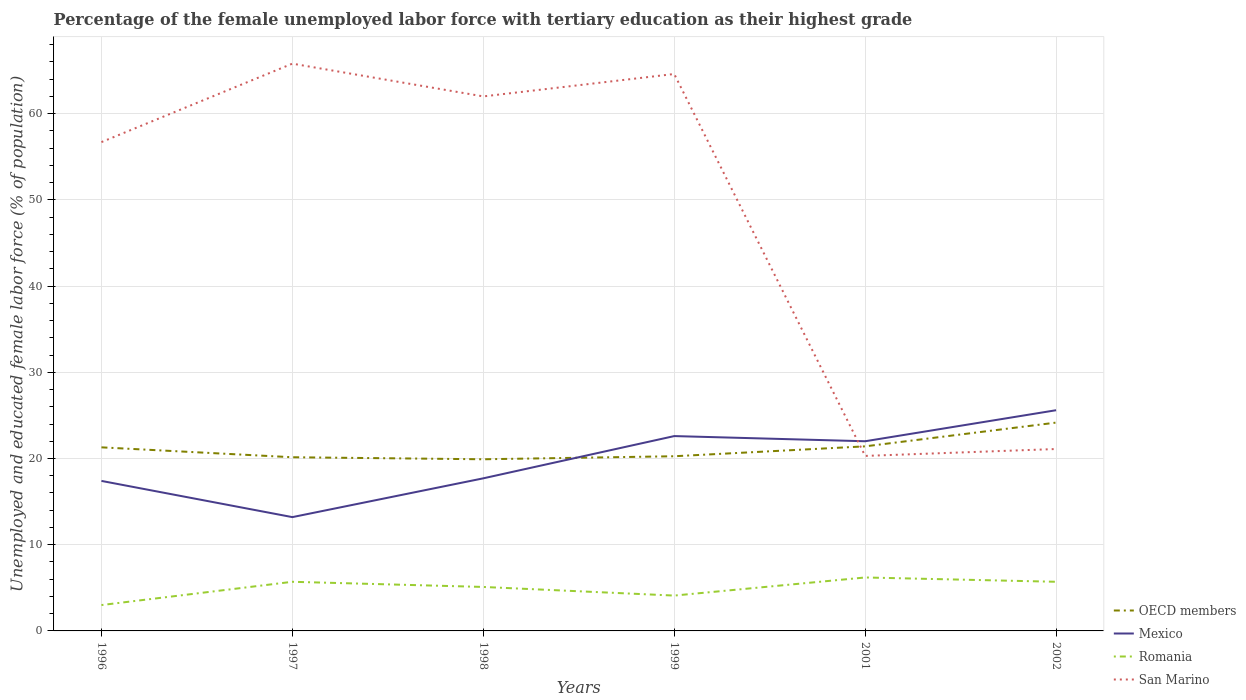Is the number of lines equal to the number of legend labels?
Provide a short and direct response. Yes. Across all years, what is the maximum percentage of the unemployed female labor force with tertiary education in San Marino?
Ensure brevity in your answer.  20.3. What is the total percentage of the unemployed female labor force with tertiary education in Mexico in the graph?
Make the answer very short. -5.2. What is the difference between the highest and the second highest percentage of the unemployed female labor force with tertiary education in OECD members?
Provide a succinct answer. 4.25. What is the difference between the highest and the lowest percentage of the unemployed female labor force with tertiary education in Mexico?
Keep it short and to the point. 3. What is the difference between two consecutive major ticks on the Y-axis?
Keep it short and to the point. 10. Are the values on the major ticks of Y-axis written in scientific E-notation?
Offer a very short reply. No. Does the graph contain any zero values?
Ensure brevity in your answer.  No. Does the graph contain grids?
Provide a short and direct response. Yes. Where does the legend appear in the graph?
Give a very brief answer. Bottom right. How many legend labels are there?
Ensure brevity in your answer.  4. How are the legend labels stacked?
Your response must be concise. Vertical. What is the title of the graph?
Your response must be concise. Percentage of the female unemployed labor force with tertiary education as their highest grade. What is the label or title of the Y-axis?
Keep it short and to the point. Unemployed and educated female labor force (% of population). What is the Unemployed and educated female labor force (% of population) of OECD members in 1996?
Ensure brevity in your answer.  21.29. What is the Unemployed and educated female labor force (% of population) in Mexico in 1996?
Your answer should be very brief. 17.4. What is the Unemployed and educated female labor force (% of population) in Romania in 1996?
Offer a terse response. 3. What is the Unemployed and educated female labor force (% of population) in San Marino in 1996?
Keep it short and to the point. 56.7. What is the Unemployed and educated female labor force (% of population) of OECD members in 1997?
Offer a terse response. 20.15. What is the Unemployed and educated female labor force (% of population) of Mexico in 1997?
Your answer should be compact. 13.2. What is the Unemployed and educated female labor force (% of population) in Romania in 1997?
Your answer should be very brief. 5.7. What is the Unemployed and educated female labor force (% of population) of San Marino in 1997?
Your answer should be very brief. 65.8. What is the Unemployed and educated female labor force (% of population) of OECD members in 1998?
Offer a terse response. 19.91. What is the Unemployed and educated female labor force (% of population) of Mexico in 1998?
Ensure brevity in your answer.  17.7. What is the Unemployed and educated female labor force (% of population) of Romania in 1998?
Provide a short and direct response. 5.1. What is the Unemployed and educated female labor force (% of population) of San Marino in 1998?
Give a very brief answer. 62. What is the Unemployed and educated female labor force (% of population) of OECD members in 1999?
Keep it short and to the point. 20.26. What is the Unemployed and educated female labor force (% of population) in Mexico in 1999?
Provide a short and direct response. 22.6. What is the Unemployed and educated female labor force (% of population) of Romania in 1999?
Keep it short and to the point. 4.1. What is the Unemployed and educated female labor force (% of population) in San Marino in 1999?
Your response must be concise. 64.6. What is the Unemployed and educated female labor force (% of population) in OECD members in 2001?
Provide a succinct answer. 21.41. What is the Unemployed and educated female labor force (% of population) in Mexico in 2001?
Your answer should be very brief. 22. What is the Unemployed and educated female labor force (% of population) in Romania in 2001?
Your answer should be very brief. 6.2. What is the Unemployed and educated female labor force (% of population) of San Marino in 2001?
Ensure brevity in your answer.  20.3. What is the Unemployed and educated female labor force (% of population) in OECD members in 2002?
Give a very brief answer. 24.16. What is the Unemployed and educated female labor force (% of population) in Mexico in 2002?
Keep it short and to the point. 25.6. What is the Unemployed and educated female labor force (% of population) of Romania in 2002?
Ensure brevity in your answer.  5.7. What is the Unemployed and educated female labor force (% of population) in San Marino in 2002?
Offer a very short reply. 21.1. Across all years, what is the maximum Unemployed and educated female labor force (% of population) of OECD members?
Keep it short and to the point. 24.16. Across all years, what is the maximum Unemployed and educated female labor force (% of population) of Mexico?
Keep it short and to the point. 25.6. Across all years, what is the maximum Unemployed and educated female labor force (% of population) in Romania?
Offer a terse response. 6.2. Across all years, what is the maximum Unemployed and educated female labor force (% of population) in San Marino?
Your response must be concise. 65.8. Across all years, what is the minimum Unemployed and educated female labor force (% of population) in OECD members?
Your answer should be very brief. 19.91. Across all years, what is the minimum Unemployed and educated female labor force (% of population) of Mexico?
Ensure brevity in your answer.  13.2. Across all years, what is the minimum Unemployed and educated female labor force (% of population) in Romania?
Make the answer very short. 3. Across all years, what is the minimum Unemployed and educated female labor force (% of population) in San Marino?
Ensure brevity in your answer.  20.3. What is the total Unemployed and educated female labor force (% of population) of OECD members in the graph?
Your response must be concise. 127.18. What is the total Unemployed and educated female labor force (% of population) of Mexico in the graph?
Provide a succinct answer. 118.5. What is the total Unemployed and educated female labor force (% of population) of Romania in the graph?
Provide a succinct answer. 29.8. What is the total Unemployed and educated female labor force (% of population) in San Marino in the graph?
Keep it short and to the point. 290.5. What is the difference between the Unemployed and educated female labor force (% of population) of OECD members in 1996 and that in 1997?
Give a very brief answer. 1.15. What is the difference between the Unemployed and educated female labor force (% of population) in San Marino in 1996 and that in 1997?
Your answer should be compact. -9.1. What is the difference between the Unemployed and educated female labor force (% of population) in OECD members in 1996 and that in 1998?
Provide a short and direct response. 1.38. What is the difference between the Unemployed and educated female labor force (% of population) in Romania in 1996 and that in 1998?
Provide a short and direct response. -2.1. What is the difference between the Unemployed and educated female labor force (% of population) of OECD members in 1996 and that in 1999?
Provide a succinct answer. 1.03. What is the difference between the Unemployed and educated female labor force (% of population) of OECD members in 1996 and that in 2001?
Your response must be concise. -0.12. What is the difference between the Unemployed and educated female labor force (% of population) in San Marino in 1996 and that in 2001?
Offer a terse response. 36.4. What is the difference between the Unemployed and educated female labor force (% of population) of OECD members in 1996 and that in 2002?
Provide a succinct answer. -2.87. What is the difference between the Unemployed and educated female labor force (% of population) in Mexico in 1996 and that in 2002?
Your answer should be very brief. -8.2. What is the difference between the Unemployed and educated female labor force (% of population) in San Marino in 1996 and that in 2002?
Provide a short and direct response. 35.6. What is the difference between the Unemployed and educated female labor force (% of population) of OECD members in 1997 and that in 1998?
Your response must be concise. 0.24. What is the difference between the Unemployed and educated female labor force (% of population) of Mexico in 1997 and that in 1998?
Offer a very short reply. -4.5. What is the difference between the Unemployed and educated female labor force (% of population) of Romania in 1997 and that in 1998?
Keep it short and to the point. 0.6. What is the difference between the Unemployed and educated female labor force (% of population) in OECD members in 1997 and that in 1999?
Make the answer very short. -0.12. What is the difference between the Unemployed and educated female labor force (% of population) in Romania in 1997 and that in 1999?
Ensure brevity in your answer.  1.6. What is the difference between the Unemployed and educated female labor force (% of population) of OECD members in 1997 and that in 2001?
Your answer should be very brief. -1.26. What is the difference between the Unemployed and educated female labor force (% of population) in Romania in 1997 and that in 2001?
Give a very brief answer. -0.5. What is the difference between the Unemployed and educated female labor force (% of population) of San Marino in 1997 and that in 2001?
Make the answer very short. 45.5. What is the difference between the Unemployed and educated female labor force (% of population) of OECD members in 1997 and that in 2002?
Offer a terse response. -4.02. What is the difference between the Unemployed and educated female labor force (% of population) in Mexico in 1997 and that in 2002?
Provide a succinct answer. -12.4. What is the difference between the Unemployed and educated female labor force (% of population) in San Marino in 1997 and that in 2002?
Offer a terse response. 44.7. What is the difference between the Unemployed and educated female labor force (% of population) of OECD members in 1998 and that in 1999?
Offer a terse response. -0.35. What is the difference between the Unemployed and educated female labor force (% of population) of Mexico in 1998 and that in 1999?
Ensure brevity in your answer.  -4.9. What is the difference between the Unemployed and educated female labor force (% of population) of Romania in 1998 and that in 1999?
Make the answer very short. 1. What is the difference between the Unemployed and educated female labor force (% of population) in OECD members in 1998 and that in 2001?
Provide a short and direct response. -1.5. What is the difference between the Unemployed and educated female labor force (% of population) in Mexico in 1998 and that in 2001?
Your answer should be compact. -4.3. What is the difference between the Unemployed and educated female labor force (% of population) in San Marino in 1998 and that in 2001?
Offer a terse response. 41.7. What is the difference between the Unemployed and educated female labor force (% of population) in OECD members in 1998 and that in 2002?
Ensure brevity in your answer.  -4.25. What is the difference between the Unemployed and educated female labor force (% of population) of Romania in 1998 and that in 2002?
Your answer should be very brief. -0.6. What is the difference between the Unemployed and educated female labor force (% of population) in San Marino in 1998 and that in 2002?
Ensure brevity in your answer.  40.9. What is the difference between the Unemployed and educated female labor force (% of population) in OECD members in 1999 and that in 2001?
Make the answer very short. -1.15. What is the difference between the Unemployed and educated female labor force (% of population) of Romania in 1999 and that in 2001?
Keep it short and to the point. -2.1. What is the difference between the Unemployed and educated female labor force (% of population) in San Marino in 1999 and that in 2001?
Your response must be concise. 44.3. What is the difference between the Unemployed and educated female labor force (% of population) in OECD members in 1999 and that in 2002?
Provide a short and direct response. -3.9. What is the difference between the Unemployed and educated female labor force (% of population) of Mexico in 1999 and that in 2002?
Ensure brevity in your answer.  -3. What is the difference between the Unemployed and educated female labor force (% of population) in Romania in 1999 and that in 2002?
Keep it short and to the point. -1.6. What is the difference between the Unemployed and educated female labor force (% of population) of San Marino in 1999 and that in 2002?
Provide a succinct answer. 43.5. What is the difference between the Unemployed and educated female labor force (% of population) in OECD members in 2001 and that in 2002?
Make the answer very short. -2.75. What is the difference between the Unemployed and educated female labor force (% of population) of Romania in 2001 and that in 2002?
Your response must be concise. 0.5. What is the difference between the Unemployed and educated female labor force (% of population) in San Marino in 2001 and that in 2002?
Your response must be concise. -0.8. What is the difference between the Unemployed and educated female labor force (% of population) in OECD members in 1996 and the Unemployed and educated female labor force (% of population) in Mexico in 1997?
Give a very brief answer. 8.09. What is the difference between the Unemployed and educated female labor force (% of population) of OECD members in 1996 and the Unemployed and educated female labor force (% of population) of Romania in 1997?
Your answer should be compact. 15.59. What is the difference between the Unemployed and educated female labor force (% of population) in OECD members in 1996 and the Unemployed and educated female labor force (% of population) in San Marino in 1997?
Offer a very short reply. -44.51. What is the difference between the Unemployed and educated female labor force (% of population) in Mexico in 1996 and the Unemployed and educated female labor force (% of population) in Romania in 1997?
Give a very brief answer. 11.7. What is the difference between the Unemployed and educated female labor force (% of population) of Mexico in 1996 and the Unemployed and educated female labor force (% of population) of San Marino in 1997?
Your response must be concise. -48.4. What is the difference between the Unemployed and educated female labor force (% of population) of Romania in 1996 and the Unemployed and educated female labor force (% of population) of San Marino in 1997?
Give a very brief answer. -62.8. What is the difference between the Unemployed and educated female labor force (% of population) of OECD members in 1996 and the Unemployed and educated female labor force (% of population) of Mexico in 1998?
Offer a terse response. 3.59. What is the difference between the Unemployed and educated female labor force (% of population) of OECD members in 1996 and the Unemployed and educated female labor force (% of population) of Romania in 1998?
Provide a short and direct response. 16.19. What is the difference between the Unemployed and educated female labor force (% of population) of OECD members in 1996 and the Unemployed and educated female labor force (% of population) of San Marino in 1998?
Your answer should be compact. -40.71. What is the difference between the Unemployed and educated female labor force (% of population) of Mexico in 1996 and the Unemployed and educated female labor force (% of population) of San Marino in 1998?
Your response must be concise. -44.6. What is the difference between the Unemployed and educated female labor force (% of population) of Romania in 1996 and the Unemployed and educated female labor force (% of population) of San Marino in 1998?
Provide a short and direct response. -59. What is the difference between the Unemployed and educated female labor force (% of population) of OECD members in 1996 and the Unemployed and educated female labor force (% of population) of Mexico in 1999?
Keep it short and to the point. -1.31. What is the difference between the Unemployed and educated female labor force (% of population) of OECD members in 1996 and the Unemployed and educated female labor force (% of population) of Romania in 1999?
Your answer should be very brief. 17.19. What is the difference between the Unemployed and educated female labor force (% of population) in OECD members in 1996 and the Unemployed and educated female labor force (% of population) in San Marino in 1999?
Your response must be concise. -43.31. What is the difference between the Unemployed and educated female labor force (% of population) in Mexico in 1996 and the Unemployed and educated female labor force (% of population) in San Marino in 1999?
Your response must be concise. -47.2. What is the difference between the Unemployed and educated female labor force (% of population) of Romania in 1996 and the Unemployed and educated female labor force (% of population) of San Marino in 1999?
Make the answer very short. -61.6. What is the difference between the Unemployed and educated female labor force (% of population) of OECD members in 1996 and the Unemployed and educated female labor force (% of population) of Mexico in 2001?
Keep it short and to the point. -0.71. What is the difference between the Unemployed and educated female labor force (% of population) of OECD members in 1996 and the Unemployed and educated female labor force (% of population) of Romania in 2001?
Ensure brevity in your answer.  15.09. What is the difference between the Unemployed and educated female labor force (% of population) of Mexico in 1996 and the Unemployed and educated female labor force (% of population) of Romania in 2001?
Keep it short and to the point. 11.2. What is the difference between the Unemployed and educated female labor force (% of population) in Romania in 1996 and the Unemployed and educated female labor force (% of population) in San Marino in 2001?
Your response must be concise. -17.3. What is the difference between the Unemployed and educated female labor force (% of population) in OECD members in 1996 and the Unemployed and educated female labor force (% of population) in Mexico in 2002?
Make the answer very short. -4.31. What is the difference between the Unemployed and educated female labor force (% of population) in OECD members in 1996 and the Unemployed and educated female labor force (% of population) in Romania in 2002?
Your answer should be very brief. 15.59. What is the difference between the Unemployed and educated female labor force (% of population) in OECD members in 1996 and the Unemployed and educated female labor force (% of population) in San Marino in 2002?
Your response must be concise. 0.19. What is the difference between the Unemployed and educated female labor force (% of population) of Romania in 1996 and the Unemployed and educated female labor force (% of population) of San Marino in 2002?
Ensure brevity in your answer.  -18.1. What is the difference between the Unemployed and educated female labor force (% of population) in OECD members in 1997 and the Unemployed and educated female labor force (% of population) in Mexico in 1998?
Give a very brief answer. 2.45. What is the difference between the Unemployed and educated female labor force (% of population) of OECD members in 1997 and the Unemployed and educated female labor force (% of population) of Romania in 1998?
Offer a terse response. 15.05. What is the difference between the Unemployed and educated female labor force (% of population) in OECD members in 1997 and the Unemployed and educated female labor force (% of population) in San Marino in 1998?
Ensure brevity in your answer.  -41.85. What is the difference between the Unemployed and educated female labor force (% of population) of Mexico in 1997 and the Unemployed and educated female labor force (% of population) of San Marino in 1998?
Make the answer very short. -48.8. What is the difference between the Unemployed and educated female labor force (% of population) in Romania in 1997 and the Unemployed and educated female labor force (% of population) in San Marino in 1998?
Offer a very short reply. -56.3. What is the difference between the Unemployed and educated female labor force (% of population) of OECD members in 1997 and the Unemployed and educated female labor force (% of population) of Mexico in 1999?
Provide a succinct answer. -2.45. What is the difference between the Unemployed and educated female labor force (% of population) of OECD members in 1997 and the Unemployed and educated female labor force (% of population) of Romania in 1999?
Give a very brief answer. 16.05. What is the difference between the Unemployed and educated female labor force (% of population) of OECD members in 1997 and the Unemployed and educated female labor force (% of population) of San Marino in 1999?
Your response must be concise. -44.45. What is the difference between the Unemployed and educated female labor force (% of population) in Mexico in 1997 and the Unemployed and educated female labor force (% of population) in San Marino in 1999?
Your answer should be compact. -51.4. What is the difference between the Unemployed and educated female labor force (% of population) of Romania in 1997 and the Unemployed and educated female labor force (% of population) of San Marino in 1999?
Provide a succinct answer. -58.9. What is the difference between the Unemployed and educated female labor force (% of population) of OECD members in 1997 and the Unemployed and educated female labor force (% of population) of Mexico in 2001?
Provide a succinct answer. -1.85. What is the difference between the Unemployed and educated female labor force (% of population) of OECD members in 1997 and the Unemployed and educated female labor force (% of population) of Romania in 2001?
Give a very brief answer. 13.95. What is the difference between the Unemployed and educated female labor force (% of population) in OECD members in 1997 and the Unemployed and educated female labor force (% of population) in San Marino in 2001?
Your answer should be compact. -0.15. What is the difference between the Unemployed and educated female labor force (% of population) in Romania in 1997 and the Unemployed and educated female labor force (% of population) in San Marino in 2001?
Keep it short and to the point. -14.6. What is the difference between the Unemployed and educated female labor force (% of population) in OECD members in 1997 and the Unemployed and educated female labor force (% of population) in Mexico in 2002?
Make the answer very short. -5.45. What is the difference between the Unemployed and educated female labor force (% of population) in OECD members in 1997 and the Unemployed and educated female labor force (% of population) in Romania in 2002?
Provide a short and direct response. 14.45. What is the difference between the Unemployed and educated female labor force (% of population) of OECD members in 1997 and the Unemployed and educated female labor force (% of population) of San Marino in 2002?
Make the answer very short. -0.95. What is the difference between the Unemployed and educated female labor force (% of population) in Mexico in 1997 and the Unemployed and educated female labor force (% of population) in San Marino in 2002?
Offer a terse response. -7.9. What is the difference between the Unemployed and educated female labor force (% of population) of Romania in 1997 and the Unemployed and educated female labor force (% of population) of San Marino in 2002?
Your response must be concise. -15.4. What is the difference between the Unemployed and educated female labor force (% of population) in OECD members in 1998 and the Unemployed and educated female labor force (% of population) in Mexico in 1999?
Your answer should be very brief. -2.69. What is the difference between the Unemployed and educated female labor force (% of population) in OECD members in 1998 and the Unemployed and educated female labor force (% of population) in Romania in 1999?
Ensure brevity in your answer.  15.81. What is the difference between the Unemployed and educated female labor force (% of population) in OECD members in 1998 and the Unemployed and educated female labor force (% of population) in San Marino in 1999?
Your answer should be compact. -44.69. What is the difference between the Unemployed and educated female labor force (% of population) in Mexico in 1998 and the Unemployed and educated female labor force (% of population) in Romania in 1999?
Give a very brief answer. 13.6. What is the difference between the Unemployed and educated female labor force (% of population) of Mexico in 1998 and the Unemployed and educated female labor force (% of population) of San Marino in 1999?
Keep it short and to the point. -46.9. What is the difference between the Unemployed and educated female labor force (% of population) of Romania in 1998 and the Unemployed and educated female labor force (% of population) of San Marino in 1999?
Provide a succinct answer. -59.5. What is the difference between the Unemployed and educated female labor force (% of population) in OECD members in 1998 and the Unemployed and educated female labor force (% of population) in Mexico in 2001?
Make the answer very short. -2.09. What is the difference between the Unemployed and educated female labor force (% of population) of OECD members in 1998 and the Unemployed and educated female labor force (% of population) of Romania in 2001?
Provide a succinct answer. 13.71. What is the difference between the Unemployed and educated female labor force (% of population) of OECD members in 1998 and the Unemployed and educated female labor force (% of population) of San Marino in 2001?
Ensure brevity in your answer.  -0.39. What is the difference between the Unemployed and educated female labor force (% of population) of Mexico in 1998 and the Unemployed and educated female labor force (% of population) of San Marino in 2001?
Your answer should be compact. -2.6. What is the difference between the Unemployed and educated female labor force (% of population) of Romania in 1998 and the Unemployed and educated female labor force (% of population) of San Marino in 2001?
Make the answer very short. -15.2. What is the difference between the Unemployed and educated female labor force (% of population) of OECD members in 1998 and the Unemployed and educated female labor force (% of population) of Mexico in 2002?
Your response must be concise. -5.69. What is the difference between the Unemployed and educated female labor force (% of population) in OECD members in 1998 and the Unemployed and educated female labor force (% of population) in Romania in 2002?
Provide a short and direct response. 14.21. What is the difference between the Unemployed and educated female labor force (% of population) of OECD members in 1998 and the Unemployed and educated female labor force (% of population) of San Marino in 2002?
Ensure brevity in your answer.  -1.19. What is the difference between the Unemployed and educated female labor force (% of population) of Mexico in 1998 and the Unemployed and educated female labor force (% of population) of San Marino in 2002?
Your answer should be very brief. -3.4. What is the difference between the Unemployed and educated female labor force (% of population) in OECD members in 1999 and the Unemployed and educated female labor force (% of population) in Mexico in 2001?
Keep it short and to the point. -1.74. What is the difference between the Unemployed and educated female labor force (% of population) of OECD members in 1999 and the Unemployed and educated female labor force (% of population) of Romania in 2001?
Make the answer very short. 14.06. What is the difference between the Unemployed and educated female labor force (% of population) in OECD members in 1999 and the Unemployed and educated female labor force (% of population) in San Marino in 2001?
Provide a short and direct response. -0.04. What is the difference between the Unemployed and educated female labor force (% of population) of Romania in 1999 and the Unemployed and educated female labor force (% of population) of San Marino in 2001?
Offer a terse response. -16.2. What is the difference between the Unemployed and educated female labor force (% of population) of OECD members in 1999 and the Unemployed and educated female labor force (% of population) of Mexico in 2002?
Offer a very short reply. -5.34. What is the difference between the Unemployed and educated female labor force (% of population) in OECD members in 1999 and the Unemployed and educated female labor force (% of population) in Romania in 2002?
Your response must be concise. 14.56. What is the difference between the Unemployed and educated female labor force (% of population) of OECD members in 1999 and the Unemployed and educated female labor force (% of population) of San Marino in 2002?
Provide a short and direct response. -0.84. What is the difference between the Unemployed and educated female labor force (% of population) of Mexico in 1999 and the Unemployed and educated female labor force (% of population) of Romania in 2002?
Offer a terse response. 16.9. What is the difference between the Unemployed and educated female labor force (% of population) of OECD members in 2001 and the Unemployed and educated female labor force (% of population) of Mexico in 2002?
Provide a succinct answer. -4.19. What is the difference between the Unemployed and educated female labor force (% of population) of OECD members in 2001 and the Unemployed and educated female labor force (% of population) of Romania in 2002?
Your answer should be very brief. 15.71. What is the difference between the Unemployed and educated female labor force (% of population) of OECD members in 2001 and the Unemployed and educated female labor force (% of population) of San Marino in 2002?
Provide a short and direct response. 0.31. What is the difference between the Unemployed and educated female labor force (% of population) in Mexico in 2001 and the Unemployed and educated female labor force (% of population) in San Marino in 2002?
Make the answer very short. 0.9. What is the difference between the Unemployed and educated female labor force (% of population) of Romania in 2001 and the Unemployed and educated female labor force (% of population) of San Marino in 2002?
Your answer should be compact. -14.9. What is the average Unemployed and educated female labor force (% of population) of OECD members per year?
Make the answer very short. 21.2. What is the average Unemployed and educated female labor force (% of population) in Mexico per year?
Ensure brevity in your answer.  19.75. What is the average Unemployed and educated female labor force (% of population) of Romania per year?
Your response must be concise. 4.97. What is the average Unemployed and educated female labor force (% of population) of San Marino per year?
Ensure brevity in your answer.  48.42. In the year 1996, what is the difference between the Unemployed and educated female labor force (% of population) in OECD members and Unemployed and educated female labor force (% of population) in Mexico?
Offer a very short reply. 3.89. In the year 1996, what is the difference between the Unemployed and educated female labor force (% of population) in OECD members and Unemployed and educated female labor force (% of population) in Romania?
Provide a short and direct response. 18.29. In the year 1996, what is the difference between the Unemployed and educated female labor force (% of population) in OECD members and Unemployed and educated female labor force (% of population) in San Marino?
Offer a very short reply. -35.41. In the year 1996, what is the difference between the Unemployed and educated female labor force (% of population) in Mexico and Unemployed and educated female labor force (% of population) in San Marino?
Make the answer very short. -39.3. In the year 1996, what is the difference between the Unemployed and educated female labor force (% of population) of Romania and Unemployed and educated female labor force (% of population) of San Marino?
Make the answer very short. -53.7. In the year 1997, what is the difference between the Unemployed and educated female labor force (% of population) of OECD members and Unemployed and educated female labor force (% of population) of Mexico?
Offer a terse response. 6.95. In the year 1997, what is the difference between the Unemployed and educated female labor force (% of population) in OECD members and Unemployed and educated female labor force (% of population) in Romania?
Offer a terse response. 14.45. In the year 1997, what is the difference between the Unemployed and educated female labor force (% of population) in OECD members and Unemployed and educated female labor force (% of population) in San Marino?
Provide a succinct answer. -45.65. In the year 1997, what is the difference between the Unemployed and educated female labor force (% of population) in Mexico and Unemployed and educated female labor force (% of population) in Romania?
Your answer should be very brief. 7.5. In the year 1997, what is the difference between the Unemployed and educated female labor force (% of population) in Mexico and Unemployed and educated female labor force (% of population) in San Marino?
Keep it short and to the point. -52.6. In the year 1997, what is the difference between the Unemployed and educated female labor force (% of population) in Romania and Unemployed and educated female labor force (% of population) in San Marino?
Give a very brief answer. -60.1. In the year 1998, what is the difference between the Unemployed and educated female labor force (% of population) of OECD members and Unemployed and educated female labor force (% of population) of Mexico?
Offer a terse response. 2.21. In the year 1998, what is the difference between the Unemployed and educated female labor force (% of population) of OECD members and Unemployed and educated female labor force (% of population) of Romania?
Your response must be concise. 14.81. In the year 1998, what is the difference between the Unemployed and educated female labor force (% of population) of OECD members and Unemployed and educated female labor force (% of population) of San Marino?
Provide a succinct answer. -42.09. In the year 1998, what is the difference between the Unemployed and educated female labor force (% of population) of Mexico and Unemployed and educated female labor force (% of population) of Romania?
Provide a short and direct response. 12.6. In the year 1998, what is the difference between the Unemployed and educated female labor force (% of population) of Mexico and Unemployed and educated female labor force (% of population) of San Marino?
Keep it short and to the point. -44.3. In the year 1998, what is the difference between the Unemployed and educated female labor force (% of population) of Romania and Unemployed and educated female labor force (% of population) of San Marino?
Your response must be concise. -56.9. In the year 1999, what is the difference between the Unemployed and educated female labor force (% of population) in OECD members and Unemployed and educated female labor force (% of population) in Mexico?
Provide a short and direct response. -2.34. In the year 1999, what is the difference between the Unemployed and educated female labor force (% of population) of OECD members and Unemployed and educated female labor force (% of population) of Romania?
Offer a very short reply. 16.16. In the year 1999, what is the difference between the Unemployed and educated female labor force (% of population) in OECD members and Unemployed and educated female labor force (% of population) in San Marino?
Your answer should be very brief. -44.34. In the year 1999, what is the difference between the Unemployed and educated female labor force (% of population) in Mexico and Unemployed and educated female labor force (% of population) in San Marino?
Make the answer very short. -42. In the year 1999, what is the difference between the Unemployed and educated female labor force (% of population) of Romania and Unemployed and educated female labor force (% of population) of San Marino?
Give a very brief answer. -60.5. In the year 2001, what is the difference between the Unemployed and educated female labor force (% of population) in OECD members and Unemployed and educated female labor force (% of population) in Mexico?
Ensure brevity in your answer.  -0.59. In the year 2001, what is the difference between the Unemployed and educated female labor force (% of population) of OECD members and Unemployed and educated female labor force (% of population) of Romania?
Keep it short and to the point. 15.21. In the year 2001, what is the difference between the Unemployed and educated female labor force (% of population) in OECD members and Unemployed and educated female labor force (% of population) in San Marino?
Your answer should be very brief. 1.11. In the year 2001, what is the difference between the Unemployed and educated female labor force (% of population) of Mexico and Unemployed and educated female labor force (% of population) of Romania?
Offer a terse response. 15.8. In the year 2001, what is the difference between the Unemployed and educated female labor force (% of population) of Mexico and Unemployed and educated female labor force (% of population) of San Marino?
Offer a very short reply. 1.7. In the year 2001, what is the difference between the Unemployed and educated female labor force (% of population) in Romania and Unemployed and educated female labor force (% of population) in San Marino?
Your answer should be very brief. -14.1. In the year 2002, what is the difference between the Unemployed and educated female labor force (% of population) in OECD members and Unemployed and educated female labor force (% of population) in Mexico?
Provide a succinct answer. -1.44. In the year 2002, what is the difference between the Unemployed and educated female labor force (% of population) in OECD members and Unemployed and educated female labor force (% of population) in Romania?
Your response must be concise. 18.46. In the year 2002, what is the difference between the Unemployed and educated female labor force (% of population) in OECD members and Unemployed and educated female labor force (% of population) in San Marino?
Provide a short and direct response. 3.06. In the year 2002, what is the difference between the Unemployed and educated female labor force (% of population) in Mexico and Unemployed and educated female labor force (% of population) in Romania?
Your answer should be very brief. 19.9. In the year 2002, what is the difference between the Unemployed and educated female labor force (% of population) of Mexico and Unemployed and educated female labor force (% of population) of San Marino?
Provide a short and direct response. 4.5. In the year 2002, what is the difference between the Unemployed and educated female labor force (% of population) of Romania and Unemployed and educated female labor force (% of population) of San Marino?
Your answer should be very brief. -15.4. What is the ratio of the Unemployed and educated female labor force (% of population) in OECD members in 1996 to that in 1997?
Make the answer very short. 1.06. What is the ratio of the Unemployed and educated female labor force (% of population) in Mexico in 1996 to that in 1997?
Your answer should be compact. 1.32. What is the ratio of the Unemployed and educated female labor force (% of population) in Romania in 1996 to that in 1997?
Provide a short and direct response. 0.53. What is the ratio of the Unemployed and educated female labor force (% of population) of San Marino in 1996 to that in 1997?
Ensure brevity in your answer.  0.86. What is the ratio of the Unemployed and educated female labor force (% of population) of OECD members in 1996 to that in 1998?
Offer a terse response. 1.07. What is the ratio of the Unemployed and educated female labor force (% of population) of Mexico in 1996 to that in 1998?
Keep it short and to the point. 0.98. What is the ratio of the Unemployed and educated female labor force (% of population) of Romania in 1996 to that in 1998?
Keep it short and to the point. 0.59. What is the ratio of the Unemployed and educated female labor force (% of population) in San Marino in 1996 to that in 1998?
Provide a short and direct response. 0.91. What is the ratio of the Unemployed and educated female labor force (% of population) in OECD members in 1996 to that in 1999?
Your response must be concise. 1.05. What is the ratio of the Unemployed and educated female labor force (% of population) in Mexico in 1996 to that in 1999?
Provide a short and direct response. 0.77. What is the ratio of the Unemployed and educated female labor force (% of population) of Romania in 1996 to that in 1999?
Keep it short and to the point. 0.73. What is the ratio of the Unemployed and educated female labor force (% of population) in San Marino in 1996 to that in 1999?
Provide a short and direct response. 0.88. What is the ratio of the Unemployed and educated female labor force (% of population) of OECD members in 1996 to that in 2001?
Keep it short and to the point. 0.99. What is the ratio of the Unemployed and educated female labor force (% of population) of Mexico in 1996 to that in 2001?
Offer a very short reply. 0.79. What is the ratio of the Unemployed and educated female labor force (% of population) in Romania in 1996 to that in 2001?
Offer a very short reply. 0.48. What is the ratio of the Unemployed and educated female labor force (% of population) in San Marino in 1996 to that in 2001?
Provide a short and direct response. 2.79. What is the ratio of the Unemployed and educated female labor force (% of population) in OECD members in 1996 to that in 2002?
Give a very brief answer. 0.88. What is the ratio of the Unemployed and educated female labor force (% of population) of Mexico in 1996 to that in 2002?
Make the answer very short. 0.68. What is the ratio of the Unemployed and educated female labor force (% of population) in Romania in 1996 to that in 2002?
Provide a succinct answer. 0.53. What is the ratio of the Unemployed and educated female labor force (% of population) in San Marino in 1996 to that in 2002?
Give a very brief answer. 2.69. What is the ratio of the Unemployed and educated female labor force (% of population) of OECD members in 1997 to that in 1998?
Keep it short and to the point. 1.01. What is the ratio of the Unemployed and educated female labor force (% of population) of Mexico in 1997 to that in 1998?
Ensure brevity in your answer.  0.75. What is the ratio of the Unemployed and educated female labor force (% of population) in Romania in 1997 to that in 1998?
Your response must be concise. 1.12. What is the ratio of the Unemployed and educated female labor force (% of population) in San Marino in 1997 to that in 1998?
Offer a terse response. 1.06. What is the ratio of the Unemployed and educated female labor force (% of population) of OECD members in 1997 to that in 1999?
Your answer should be compact. 0.99. What is the ratio of the Unemployed and educated female labor force (% of population) in Mexico in 1997 to that in 1999?
Give a very brief answer. 0.58. What is the ratio of the Unemployed and educated female labor force (% of population) of Romania in 1997 to that in 1999?
Offer a terse response. 1.39. What is the ratio of the Unemployed and educated female labor force (% of population) in San Marino in 1997 to that in 1999?
Provide a succinct answer. 1.02. What is the ratio of the Unemployed and educated female labor force (% of population) of OECD members in 1997 to that in 2001?
Give a very brief answer. 0.94. What is the ratio of the Unemployed and educated female labor force (% of population) in Mexico in 1997 to that in 2001?
Ensure brevity in your answer.  0.6. What is the ratio of the Unemployed and educated female labor force (% of population) in Romania in 1997 to that in 2001?
Offer a very short reply. 0.92. What is the ratio of the Unemployed and educated female labor force (% of population) in San Marino in 1997 to that in 2001?
Your answer should be compact. 3.24. What is the ratio of the Unemployed and educated female labor force (% of population) of OECD members in 1997 to that in 2002?
Your answer should be very brief. 0.83. What is the ratio of the Unemployed and educated female labor force (% of population) of Mexico in 1997 to that in 2002?
Provide a succinct answer. 0.52. What is the ratio of the Unemployed and educated female labor force (% of population) in Romania in 1997 to that in 2002?
Your answer should be compact. 1. What is the ratio of the Unemployed and educated female labor force (% of population) in San Marino in 1997 to that in 2002?
Your answer should be very brief. 3.12. What is the ratio of the Unemployed and educated female labor force (% of population) of OECD members in 1998 to that in 1999?
Ensure brevity in your answer.  0.98. What is the ratio of the Unemployed and educated female labor force (% of population) of Mexico in 1998 to that in 1999?
Keep it short and to the point. 0.78. What is the ratio of the Unemployed and educated female labor force (% of population) in Romania in 1998 to that in 1999?
Offer a very short reply. 1.24. What is the ratio of the Unemployed and educated female labor force (% of population) in San Marino in 1998 to that in 1999?
Provide a short and direct response. 0.96. What is the ratio of the Unemployed and educated female labor force (% of population) of OECD members in 1998 to that in 2001?
Give a very brief answer. 0.93. What is the ratio of the Unemployed and educated female labor force (% of population) in Mexico in 1998 to that in 2001?
Keep it short and to the point. 0.8. What is the ratio of the Unemployed and educated female labor force (% of population) of Romania in 1998 to that in 2001?
Offer a very short reply. 0.82. What is the ratio of the Unemployed and educated female labor force (% of population) in San Marino in 1998 to that in 2001?
Your answer should be very brief. 3.05. What is the ratio of the Unemployed and educated female labor force (% of population) in OECD members in 1998 to that in 2002?
Give a very brief answer. 0.82. What is the ratio of the Unemployed and educated female labor force (% of population) in Mexico in 1998 to that in 2002?
Give a very brief answer. 0.69. What is the ratio of the Unemployed and educated female labor force (% of population) of Romania in 1998 to that in 2002?
Give a very brief answer. 0.89. What is the ratio of the Unemployed and educated female labor force (% of population) in San Marino in 1998 to that in 2002?
Provide a succinct answer. 2.94. What is the ratio of the Unemployed and educated female labor force (% of population) of OECD members in 1999 to that in 2001?
Keep it short and to the point. 0.95. What is the ratio of the Unemployed and educated female labor force (% of population) in Mexico in 1999 to that in 2001?
Give a very brief answer. 1.03. What is the ratio of the Unemployed and educated female labor force (% of population) in Romania in 1999 to that in 2001?
Offer a terse response. 0.66. What is the ratio of the Unemployed and educated female labor force (% of population) in San Marino in 1999 to that in 2001?
Ensure brevity in your answer.  3.18. What is the ratio of the Unemployed and educated female labor force (% of population) of OECD members in 1999 to that in 2002?
Give a very brief answer. 0.84. What is the ratio of the Unemployed and educated female labor force (% of population) of Mexico in 1999 to that in 2002?
Your answer should be very brief. 0.88. What is the ratio of the Unemployed and educated female labor force (% of population) in Romania in 1999 to that in 2002?
Make the answer very short. 0.72. What is the ratio of the Unemployed and educated female labor force (% of population) of San Marino in 1999 to that in 2002?
Your response must be concise. 3.06. What is the ratio of the Unemployed and educated female labor force (% of population) in OECD members in 2001 to that in 2002?
Ensure brevity in your answer.  0.89. What is the ratio of the Unemployed and educated female labor force (% of population) in Mexico in 2001 to that in 2002?
Provide a succinct answer. 0.86. What is the ratio of the Unemployed and educated female labor force (% of population) of Romania in 2001 to that in 2002?
Ensure brevity in your answer.  1.09. What is the ratio of the Unemployed and educated female labor force (% of population) in San Marino in 2001 to that in 2002?
Your answer should be compact. 0.96. What is the difference between the highest and the second highest Unemployed and educated female labor force (% of population) in OECD members?
Your answer should be compact. 2.75. What is the difference between the highest and the second highest Unemployed and educated female labor force (% of population) in Mexico?
Offer a very short reply. 3. What is the difference between the highest and the second highest Unemployed and educated female labor force (% of population) in San Marino?
Your answer should be very brief. 1.2. What is the difference between the highest and the lowest Unemployed and educated female labor force (% of population) of OECD members?
Give a very brief answer. 4.25. What is the difference between the highest and the lowest Unemployed and educated female labor force (% of population) of Romania?
Your answer should be very brief. 3.2. What is the difference between the highest and the lowest Unemployed and educated female labor force (% of population) of San Marino?
Your response must be concise. 45.5. 